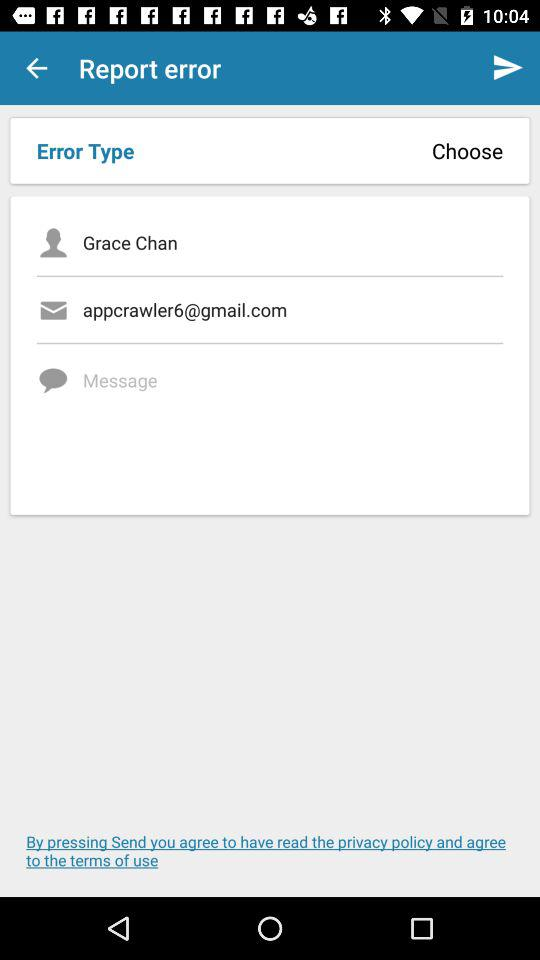What is the email address? The email address is appcrawler6@gmail.com. 